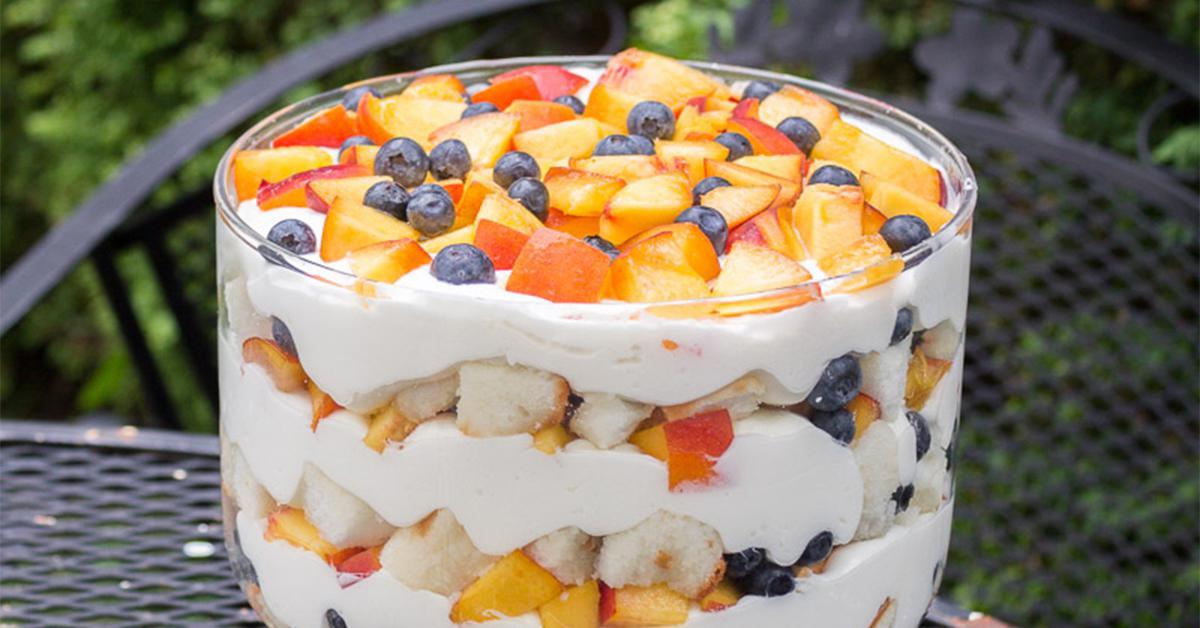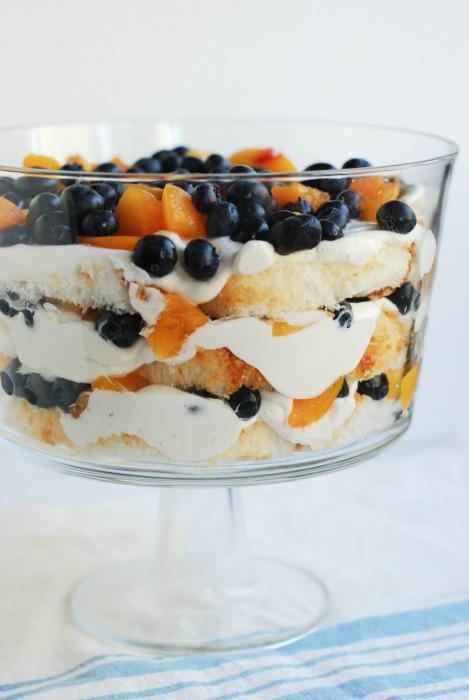The first image is the image on the left, the second image is the image on the right. Evaluate the accuracy of this statement regarding the images: "There are one or more spoons to the left of the truffle in one of the images.". Is it true? Answer yes or no. No. 